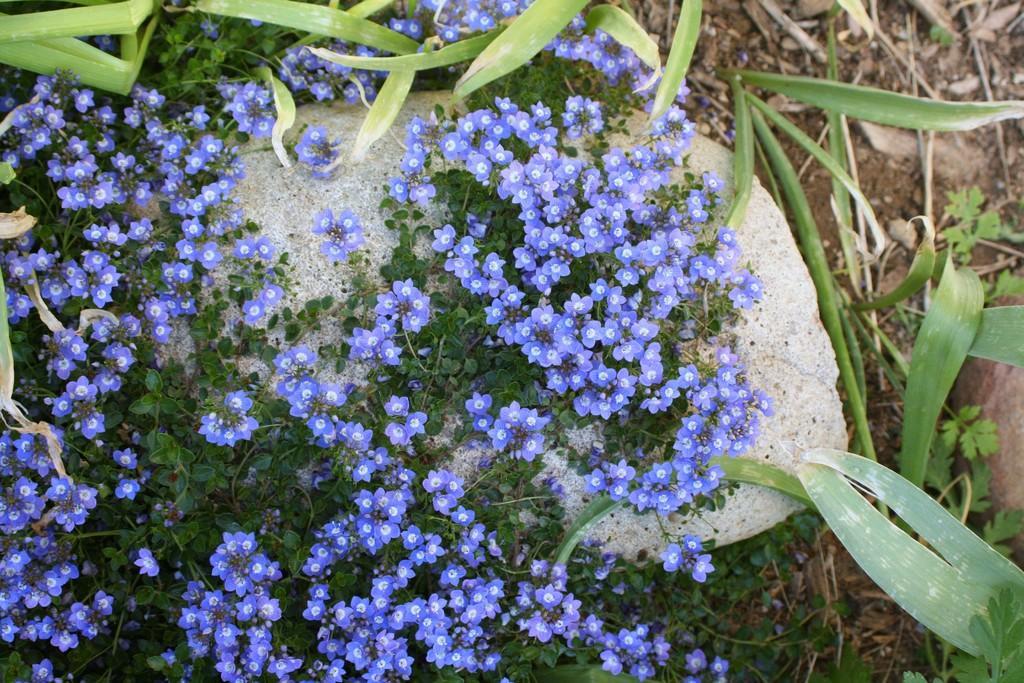Can you describe this image briefly? In this image we can see a bunch of flowers to a plant. We can also see a stone. 